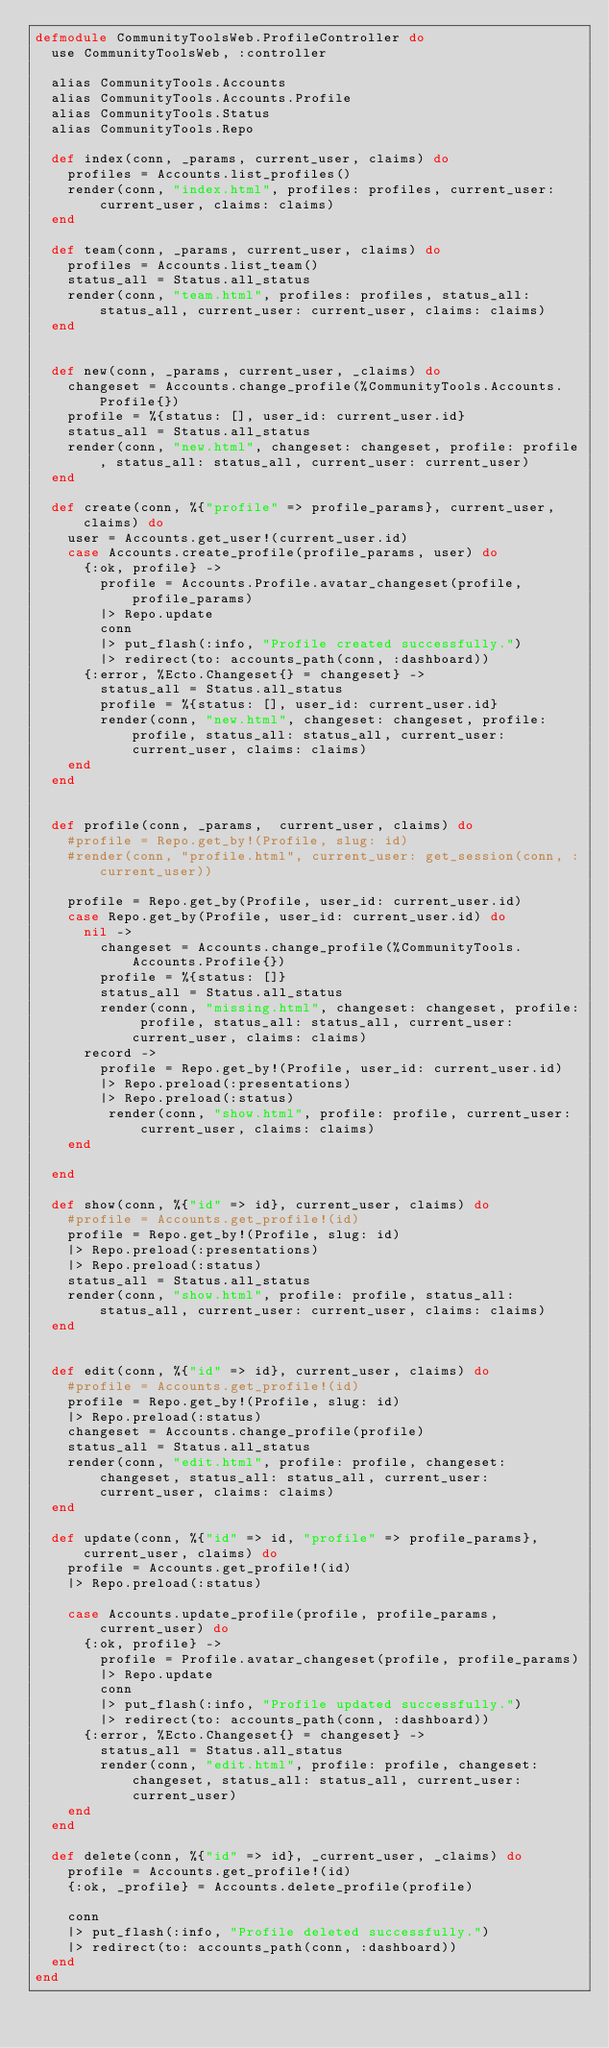Convert code to text. <code><loc_0><loc_0><loc_500><loc_500><_Elixir_>defmodule CommunityToolsWeb.ProfileController do
  use CommunityToolsWeb, :controller

  alias CommunityTools.Accounts
  alias CommunityTools.Accounts.Profile
  alias CommunityTools.Status
  alias CommunityTools.Repo

  def index(conn, _params, current_user, claims) do
    profiles = Accounts.list_profiles()
    render(conn, "index.html", profiles: profiles, current_user: current_user, claims: claims)
  end

  def team(conn, _params, current_user, claims) do
    profiles = Accounts.list_team()
    status_all = Status.all_status
    render(conn, "team.html", profiles: profiles, status_all: status_all, current_user: current_user, claims: claims)
  end


  def new(conn, _params, current_user, _claims) do
    changeset = Accounts.change_profile(%CommunityTools.Accounts.Profile{})
    profile = %{status: [], user_id: current_user.id}
    status_all = Status.all_status
    render(conn, "new.html", changeset: changeset, profile: profile, status_all: status_all, current_user: current_user)
  end

  def create(conn, %{"profile" => profile_params}, current_user, claims) do
    user = Accounts.get_user!(current_user.id)
    case Accounts.create_profile(profile_params, user) do
      {:ok, profile} ->
        profile = Accounts.Profile.avatar_changeset(profile, profile_params)
        |> Repo.update
        conn
        |> put_flash(:info, "Profile created successfully.")
        |> redirect(to: accounts_path(conn, :dashboard))
      {:error, %Ecto.Changeset{} = changeset} ->
        status_all = Status.all_status
        profile = %{status: [], user_id: current_user.id}
        render(conn, "new.html", changeset: changeset, profile: profile, status_all: status_all, current_user: current_user, claims: claims)
    end
  end


  def profile(conn, _params,  current_user, claims) do
    #profile = Repo.get_by!(Profile, slug: id)
    #render(conn, "profile.html", current_user: get_session(conn, :current_user))

    profile = Repo.get_by(Profile, user_id: current_user.id)
    case Repo.get_by(Profile, user_id: current_user.id) do
      nil ->
        changeset = Accounts.change_profile(%CommunityTools.Accounts.Profile{})
        profile = %{status: []}
        status_all = Status.all_status
        render(conn, "missing.html", changeset: changeset, profile: profile, status_all: status_all, current_user: current_user, claims: claims)
      record ->
        profile = Repo.get_by!(Profile, user_id: current_user.id)
        |> Repo.preload(:presentations)
        |> Repo.preload(:status)
         render(conn, "show.html", profile: profile, current_user: current_user, claims: claims)
    end

  end

  def show(conn, %{"id" => id}, current_user, claims) do
    #profile = Accounts.get_profile!(id)
    profile = Repo.get_by!(Profile, slug: id)
    |> Repo.preload(:presentations)
    |> Repo.preload(:status)
    status_all = Status.all_status
    render(conn, "show.html", profile: profile, status_all: status_all, current_user: current_user, claims: claims)
  end


  def edit(conn, %{"id" => id}, current_user, claims) do
    #profile = Accounts.get_profile!(id)
    profile = Repo.get_by!(Profile, slug: id)
    |> Repo.preload(:status)
    changeset = Accounts.change_profile(profile)
    status_all = Status.all_status
    render(conn, "edit.html", profile: profile, changeset: changeset, status_all: status_all, current_user: current_user, claims: claims)
  end

  def update(conn, %{"id" => id, "profile" => profile_params}, current_user, claims) do
    profile = Accounts.get_profile!(id)
    |> Repo.preload(:status)

    case Accounts.update_profile(profile, profile_params, current_user) do
      {:ok, profile} ->
        profile = Profile.avatar_changeset(profile, profile_params)
        |> Repo.update
        conn
        |> put_flash(:info, "Profile updated successfully.")
        |> redirect(to: accounts_path(conn, :dashboard))
      {:error, %Ecto.Changeset{} = changeset} ->
        status_all = Status.all_status
        render(conn, "edit.html", profile: profile, changeset: changeset, status_all: status_all, current_user: current_user)
    end
  end

  def delete(conn, %{"id" => id}, _current_user, _claims) do
    profile = Accounts.get_profile!(id)
    {:ok, _profile} = Accounts.delete_profile(profile)

    conn
    |> put_flash(:info, "Profile deleted successfully.")
    |> redirect(to: accounts_path(conn, :dashboard))
  end
end
</code> 